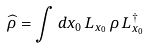Convert formula to latex. <formula><loc_0><loc_0><loc_500><loc_500>\widehat { \rho } = \int d x _ { 0 } \, L _ { x _ { 0 } } \, \rho \, L _ { x _ { 0 } } ^ { \dagger }</formula> 